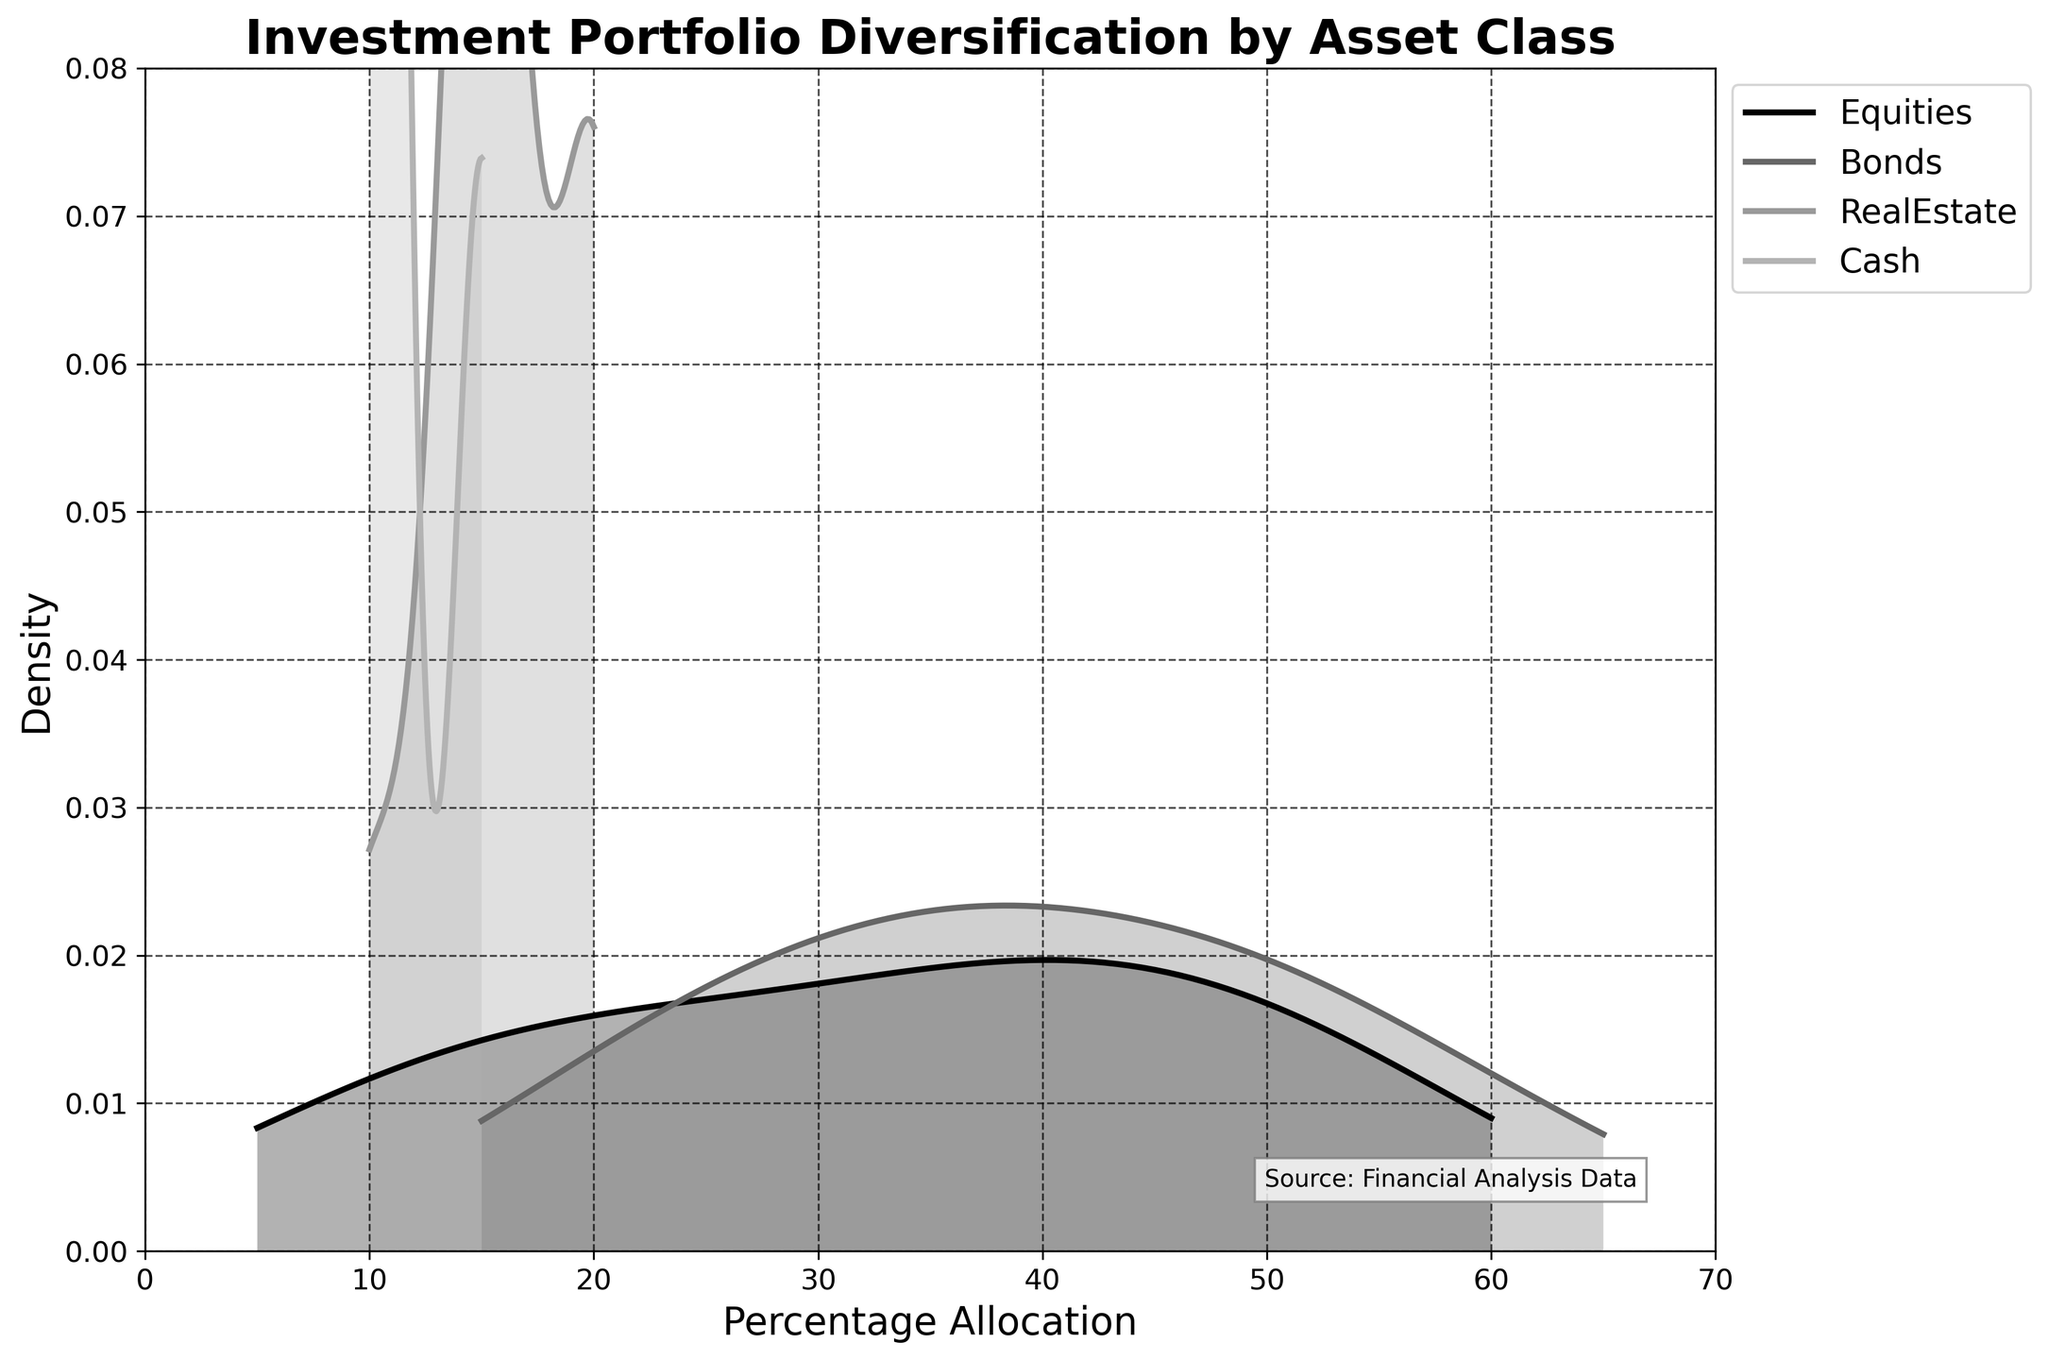what is the title of the plot? The title of the plot is located at the top of the figure in bold and large font. Simply reading the title will answer the question.
Answer: Investment Portfolio Diversification by Asset Class What percentage allocation does the x-axis represent? The x-axis label indicating the percentage allocation is at the bottom of the figure.
Answer: Percentage Allocation Which asset class has the highest peak in the density plot? To determine which asset class has the highest peak, look at which density curve reaches the highest value on the y-axis.
Answer: Bonds What are the categories present in the legend? Look at the legend located towards the right top of the plot to identify all asset classes listed.
Answer: Equities, Bonds, RealEstate, Cash Which asset class has the lowest variation in density? To determine the asset class with the lowest variation, look at the width of the distribution curve; the narrower it is, the less variation there is.
Answer: Equities What's the percentage allocation range with the highest density for Real Estate? Identify the range along the x-axis for Real Estate's density curve where the peak is highest.
Answer: 20% Comparing Equities and Bonds, which one has a broader spread of density? Comparing the width of the density curves of Equities and Bonds shows that a broader spread will have a more extended curve.
Answer: Bonds What is the upper limit of the density values on the y-axis? The y-axis scale shows the maximum value that the density reaches, found at the higher end of the axis.
Answer: 0.08 Does the Cash category have a higher density at lower or higher percentage allocations? Check the Cash density curve and see where it is more elevated along the x-axis to determine higher density at lower or higher end percentages.
Answer: Lower percentage Are there any overlapping density curves among different asset classes? Observing the plot will show if any density curves for various asset classes intersect with each other.
Answer: Yes 